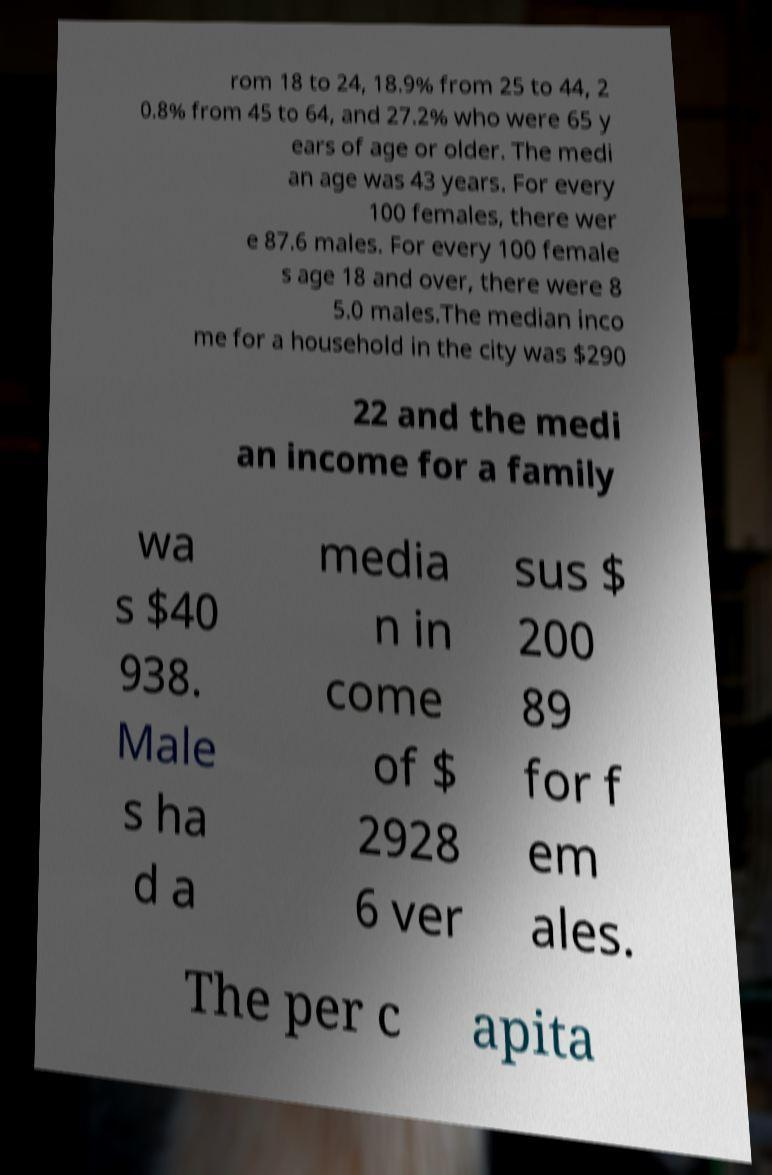Can you accurately transcribe the text from the provided image for me? rom 18 to 24, 18.9% from 25 to 44, 2 0.8% from 45 to 64, and 27.2% who were 65 y ears of age or older. The medi an age was 43 years. For every 100 females, there wer e 87.6 males. For every 100 female s age 18 and over, there were 8 5.0 males.The median inco me for a household in the city was $290 22 and the medi an income for a family wa s $40 938. Male s ha d a media n in come of $ 2928 6 ver sus $ 200 89 for f em ales. The per c apita 